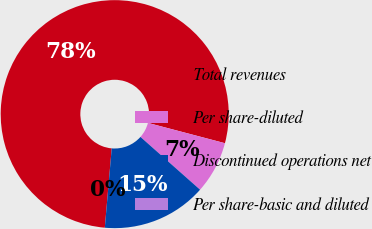Convert chart to OTSL. <chart><loc_0><loc_0><loc_500><loc_500><pie_chart><fcel>Total revenues<fcel>Per share-diluted<fcel>Discontinued operations net<fcel>Per share-basic and diluted<nl><fcel>77.72%<fcel>7.43%<fcel>14.85%<fcel>0.0%<nl></chart> 